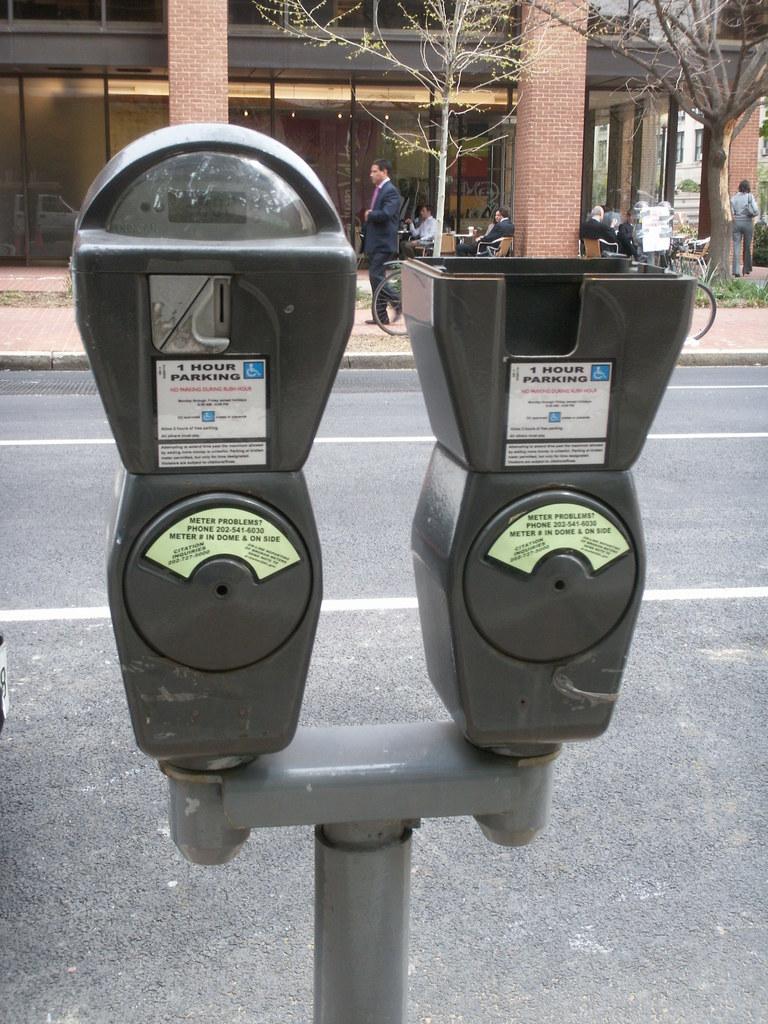What type of meter is displayed?
Keep it short and to the point. Parking. How many hours is the parking meter for?
Ensure brevity in your answer.  1. 